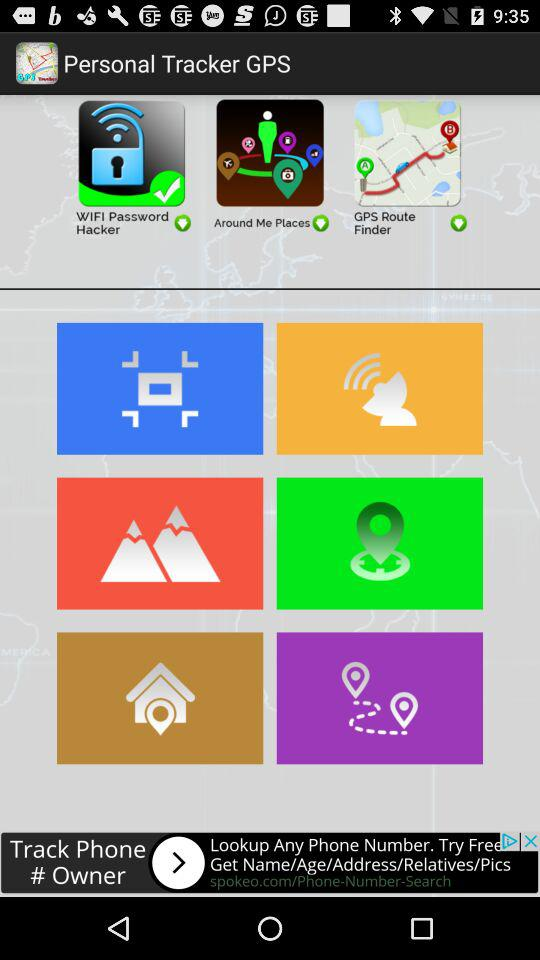What is the name of the application? The name of the application is "Personal Tracker GPS". 